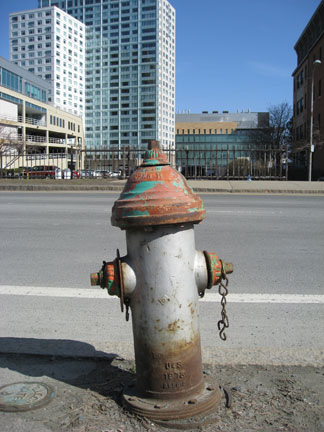<image>What letter is written in black on the side of the hydrant? I am not sure. There is no letter written in black on the hydrant or it can be any of 's', 'm', 'w', or it can be illegible. What letter is written in black on the side of the hydrant? I don't know what letter is written in black on the side of the hydrant. 